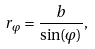Convert formula to latex. <formula><loc_0><loc_0><loc_500><loc_500>r _ { \varphi } = \frac { b } { \sin ( \varphi ) } ,</formula> 